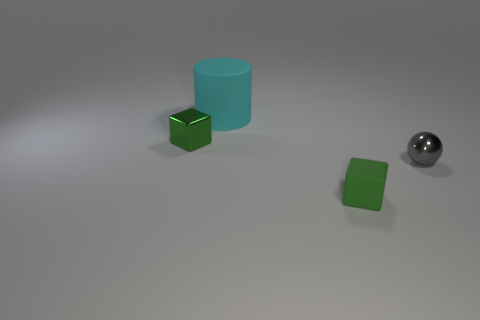Add 3 big objects. How many objects exist? 7 Subtract all cylinders. How many objects are left? 3 Subtract 1 gray spheres. How many objects are left? 3 Subtract all small cyan metal spheres. Subtract all big objects. How many objects are left? 3 Add 2 rubber cylinders. How many rubber cylinders are left? 3 Add 4 green rubber things. How many green rubber things exist? 5 